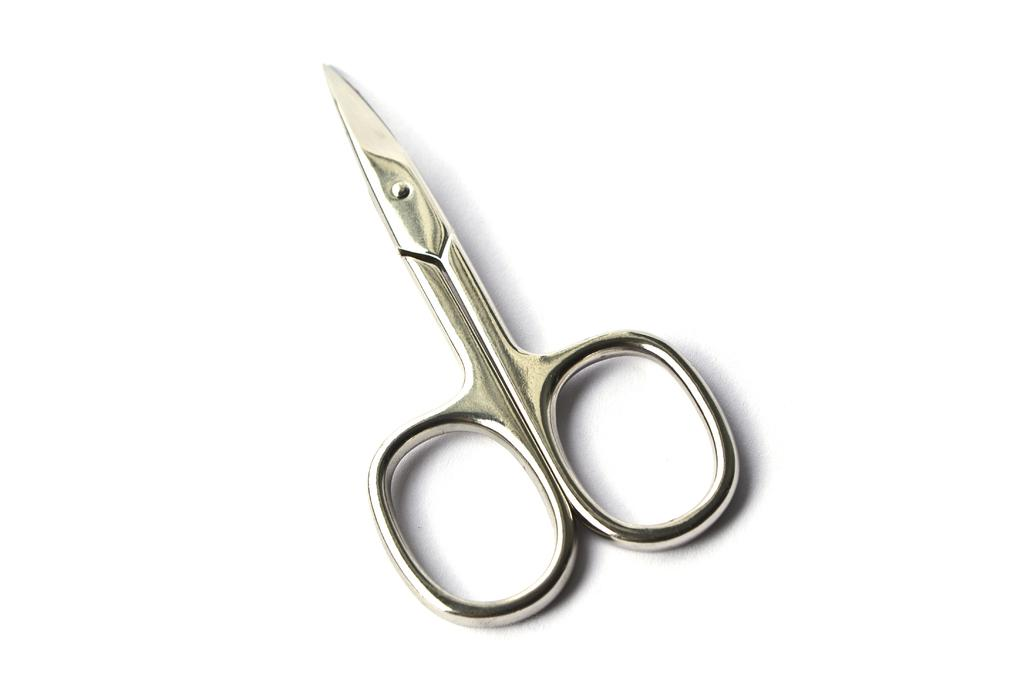What object is present in the image? There is a scissors in the image. What is the scissors placed on? The scissors is placed on a white color object. How many eyes can be seen on the scissors in the image? There are no eyes present on the scissors in the image, as scissors do not have eyes. 